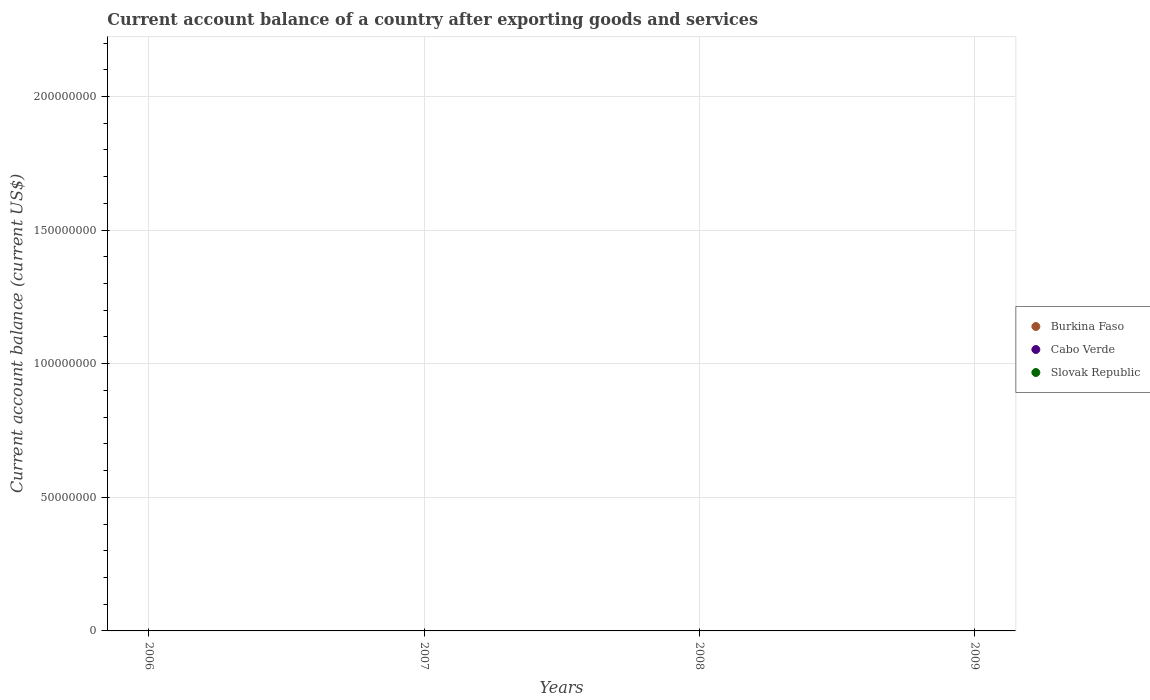How many different coloured dotlines are there?
Provide a short and direct response. 0. What is the account balance in Cabo Verde in 2009?
Give a very brief answer. 0. Across all years, what is the minimum account balance in Cabo Verde?
Your answer should be compact. 0. What is the difference between the account balance in Cabo Verde in 2009 and the account balance in Slovak Republic in 2007?
Offer a very short reply. 0. What is the average account balance in Cabo Verde per year?
Offer a terse response. 0. In how many years, is the account balance in Slovak Republic greater than 80000000 US$?
Provide a short and direct response. 0. In how many years, is the account balance in Slovak Republic greater than the average account balance in Slovak Republic taken over all years?
Offer a very short reply. 0. Is it the case that in every year, the sum of the account balance in Burkina Faso and account balance in Cabo Verde  is greater than the account balance in Slovak Republic?
Ensure brevity in your answer.  No. Is the account balance in Burkina Faso strictly less than the account balance in Slovak Republic over the years?
Ensure brevity in your answer.  No. How many years are there in the graph?
Your answer should be very brief. 4. Are the values on the major ticks of Y-axis written in scientific E-notation?
Keep it short and to the point. No. Does the graph contain grids?
Your answer should be compact. Yes. Where does the legend appear in the graph?
Your answer should be compact. Center right. How many legend labels are there?
Keep it short and to the point. 3. What is the title of the graph?
Offer a terse response. Current account balance of a country after exporting goods and services. Does "Vietnam" appear as one of the legend labels in the graph?
Keep it short and to the point. No. What is the label or title of the Y-axis?
Ensure brevity in your answer.  Current account balance (current US$). What is the Current account balance (current US$) in Burkina Faso in 2007?
Offer a terse response. 0. What is the Current account balance (current US$) of Cabo Verde in 2007?
Offer a terse response. 0. What is the Current account balance (current US$) in Slovak Republic in 2007?
Your response must be concise. 0. What is the Current account balance (current US$) in Cabo Verde in 2008?
Give a very brief answer. 0. What is the Current account balance (current US$) of Slovak Republic in 2009?
Ensure brevity in your answer.  0. What is the average Current account balance (current US$) of Burkina Faso per year?
Make the answer very short. 0. What is the average Current account balance (current US$) of Slovak Republic per year?
Your response must be concise. 0. 